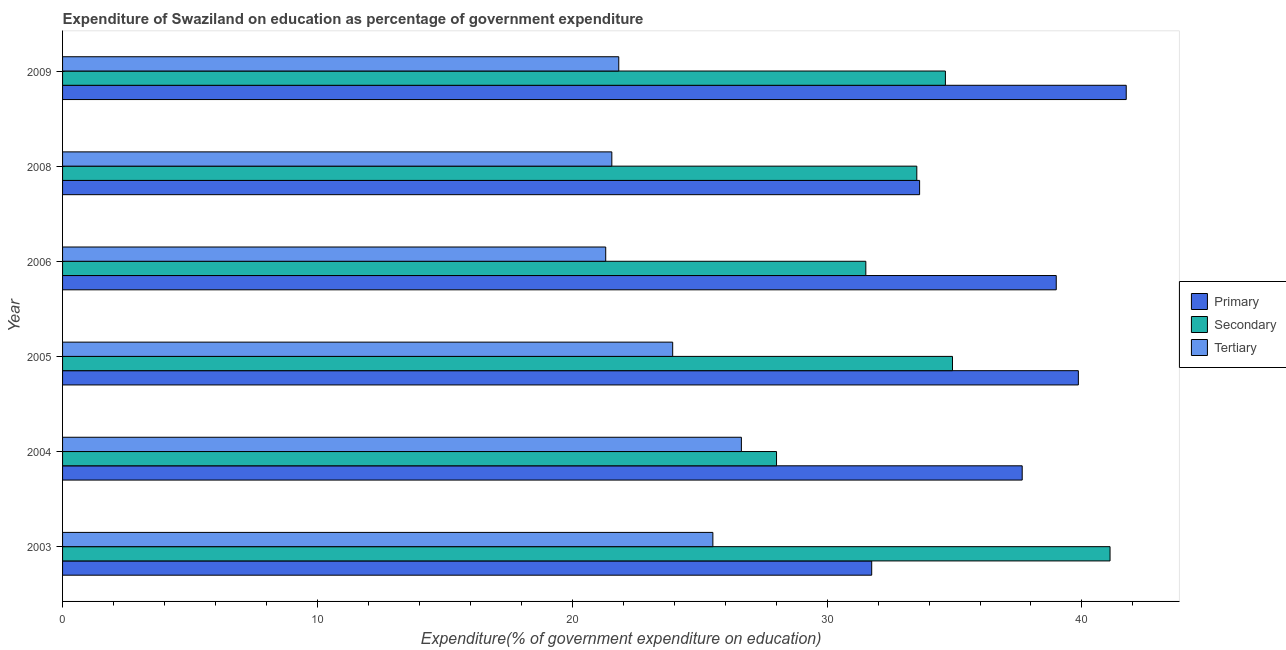Are the number of bars on each tick of the Y-axis equal?
Make the answer very short. Yes. What is the label of the 6th group of bars from the top?
Ensure brevity in your answer.  2003. What is the expenditure on secondary education in 2003?
Provide a succinct answer. 41.1. Across all years, what is the maximum expenditure on secondary education?
Offer a terse response. 41.1. Across all years, what is the minimum expenditure on primary education?
Offer a very short reply. 31.75. In which year was the expenditure on primary education maximum?
Offer a terse response. 2009. In which year was the expenditure on secondary education minimum?
Ensure brevity in your answer.  2004. What is the total expenditure on tertiary education in the graph?
Your answer should be very brief. 140.79. What is the difference between the expenditure on secondary education in 2004 and that in 2009?
Provide a short and direct response. -6.63. What is the difference between the expenditure on tertiary education in 2004 and the expenditure on primary education in 2005?
Give a very brief answer. -13.22. What is the average expenditure on tertiary education per year?
Ensure brevity in your answer.  23.46. In the year 2004, what is the difference between the expenditure on primary education and expenditure on tertiary education?
Offer a very short reply. 11.02. In how many years, is the expenditure on tertiary education greater than 10 %?
Your answer should be compact. 6. What is the ratio of the expenditure on secondary education in 2003 to that in 2005?
Your response must be concise. 1.18. What is the difference between the highest and the second highest expenditure on tertiary education?
Your answer should be compact. 1.12. What is the difference between the highest and the lowest expenditure on secondary education?
Provide a succinct answer. 13.09. In how many years, is the expenditure on primary education greater than the average expenditure on primary education taken over all years?
Make the answer very short. 4. Is the sum of the expenditure on primary education in 2003 and 2004 greater than the maximum expenditure on tertiary education across all years?
Your answer should be very brief. Yes. What does the 1st bar from the top in 2004 represents?
Offer a very short reply. Tertiary. What does the 2nd bar from the bottom in 2003 represents?
Make the answer very short. Secondary. Is it the case that in every year, the sum of the expenditure on primary education and expenditure on secondary education is greater than the expenditure on tertiary education?
Give a very brief answer. Yes. How many bars are there?
Your response must be concise. 18. How many years are there in the graph?
Offer a terse response. 6. What is the difference between two consecutive major ticks on the X-axis?
Provide a short and direct response. 10. Does the graph contain any zero values?
Make the answer very short. No. How many legend labels are there?
Offer a very short reply. 3. What is the title of the graph?
Offer a terse response. Expenditure of Swaziland on education as percentage of government expenditure. Does "Self-employed" appear as one of the legend labels in the graph?
Keep it short and to the point. No. What is the label or title of the X-axis?
Your answer should be compact. Expenditure(% of government expenditure on education). What is the label or title of the Y-axis?
Give a very brief answer. Year. What is the Expenditure(% of government expenditure on education) in Primary in 2003?
Your response must be concise. 31.75. What is the Expenditure(% of government expenditure on education) in Secondary in 2003?
Your answer should be compact. 41.1. What is the Expenditure(% of government expenditure on education) of Tertiary in 2003?
Your answer should be very brief. 25.52. What is the Expenditure(% of government expenditure on education) of Primary in 2004?
Provide a short and direct response. 37.66. What is the Expenditure(% of government expenditure on education) in Secondary in 2004?
Make the answer very short. 28.02. What is the Expenditure(% of government expenditure on education) in Tertiary in 2004?
Provide a short and direct response. 26.64. What is the Expenditure(% of government expenditure on education) of Primary in 2005?
Make the answer very short. 39.86. What is the Expenditure(% of government expenditure on education) of Secondary in 2005?
Ensure brevity in your answer.  34.92. What is the Expenditure(% of government expenditure on education) in Tertiary in 2005?
Give a very brief answer. 23.94. What is the Expenditure(% of government expenditure on education) of Primary in 2006?
Ensure brevity in your answer.  38.99. What is the Expenditure(% of government expenditure on education) of Secondary in 2006?
Ensure brevity in your answer.  31.52. What is the Expenditure(% of government expenditure on education) in Tertiary in 2006?
Your answer should be very brief. 21.31. What is the Expenditure(% of government expenditure on education) of Primary in 2008?
Your answer should be compact. 33.63. What is the Expenditure(% of government expenditure on education) in Secondary in 2008?
Your answer should be very brief. 33.52. What is the Expenditure(% of government expenditure on education) of Tertiary in 2008?
Your answer should be very brief. 21.55. What is the Expenditure(% of government expenditure on education) in Primary in 2009?
Offer a terse response. 41.74. What is the Expenditure(% of government expenditure on education) in Secondary in 2009?
Offer a terse response. 34.64. What is the Expenditure(% of government expenditure on education) in Tertiary in 2009?
Offer a terse response. 21.82. Across all years, what is the maximum Expenditure(% of government expenditure on education) of Primary?
Offer a terse response. 41.74. Across all years, what is the maximum Expenditure(% of government expenditure on education) in Secondary?
Make the answer very short. 41.1. Across all years, what is the maximum Expenditure(% of government expenditure on education) of Tertiary?
Ensure brevity in your answer.  26.64. Across all years, what is the minimum Expenditure(% of government expenditure on education) of Primary?
Give a very brief answer. 31.75. Across all years, what is the minimum Expenditure(% of government expenditure on education) of Secondary?
Offer a very short reply. 28.02. Across all years, what is the minimum Expenditure(% of government expenditure on education) of Tertiary?
Keep it short and to the point. 21.31. What is the total Expenditure(% of government expenditure on education) in Primary in the graph?
Keep it short and to the point. 223.62. What is the total Expenditure(% of government expenditure on education) in Secondary in the graph?
Provide a short and direct response. 203.72. What is the total Expenditure(% of government expenditure on education) of Tertiary in the graph?
Provide a short and direct response. 140.79. What is the difference between the Expenditure(% of government expenditure on education) of Primary in 2003 and that in 2004?
Your response must be concise. -5.91. What is the difference between the Expenditure(% of government expenditure on education) in Secondary in 2003 and that in 2004?
Keep it short and to the point. 13.09. What is the difference between the Expenditure(% of government expenditure on education) in Tertiary in 2003 and that in 2004?
Keep it short and to the point. -1.12. What is the difference between the Expenditure(% of government expenditure on education) in Primary in 2003 and that in 2005?
Your answer should be compact. -8.11. What is the difference between the Expenditure(% of government expenditure on education) in Secondary in 2003 and that in 2005?
Offer a terse response. 6.18. What is the difference between the Expenditure(% of government expenditure on education) of Tertiary in 2003 and that in 2005?
Ensure brevity in your answer.  1.58. What is the difference between the Expenditure(% of government expenditure on education) of Primary in 2003 and that in 2006?
Your response must be concise. -7.24. What is the difference between the Expenditure(% of government expenditure on education) of Secondary in 2003 and that in 2006?
Provide a short and direct response. 9.58. What is the difference between the Expenditure(% of government expenditure on education) in Tertiary in 2003 and that in 2006?
Offer a very short reply. 4.21. What is the difference between the Expenditure(% of government expenditure on education) of Primary in 2003 and that in 2008?
Your answer should be very brief. -1.88. What is the difference between the Expenditure(% of government expenditure on education) of Secondary in 2003 and that in 2008?
Make the answer very short. 7.58. What is the difference between the Expenditure(% of government expenditure on education) in Tertiary in 2003 and that in 2008?
Give a very brief answer. 3.97. What is the difference between the Expenditure(% of government expenditure on education) in Primary in 2003 and that in 2009?
Provide a succinct answer. -9.99. What is the difference between the Expenditure(% of government expenditure on education) in Secondary in 2003 and that in 2009?
Provide a short and direct response. 6.46. What is the difference between the Expenditure(% of government expenditure on education) in Tertiary in 2003 and that in 2009?
Offer a very short reply. 3.69. What is the difference between the Expenditure(% of government expenditure on education) of Primary in 2004 and that in 2005?
Make the answer very short. -2.2. What is the difference between the Expenditure(% of government expenditure on education) in Secondary in 2004 and that in 2005?
Ensure brevity in your answer.  -6.9. What is the difference between the Expenditure(% of government expenditure on education) of Tertiary in 2004 and that in 2005?
Offer a terse response. 2.7. What is the difference between the Expenditure(% of government expenditure on education) of Primary in 2004 and that in 2006?
Offer a very short reply. -1.34. What is the difference between the Expenditure(% of government expenditure on education) of Secondary in 2004 and that in 2006?
Keep it short and to the point. -3.5. What is the difference between the Expenditure(% of government expenditure on education) of Tertiary in 2004 and that in 2006?
Provide a succinct answer. 5.32. What is the difference between the Expenditure(% of government expenditure on education) of Primary in 2004 and that in 2008?
Your answer should be compact. 4.03. What is the difference between the Expenditure(% of government expenditure on education) of Secondary in 2004 and that in 2008?
Provide a short and direct response. -5.5. What is the difference between the Expenditure(% of government expenditure on education) in Tertiary in 2004 and that in 2008?
Your answer should be compact. 5.08. What is the difference between the Expenditure(% of government expenditure on education) in Primary in 2004 and that in 2009?
Your answer should be very brief. -4.08. What is the difference between the Expenditure(% of government expenditure on education) in Secondary in 2004 and that in 2009?
Make the answer very short. -6.63. What is the difference between the Expenditure(% of government expenditure on education) in Tertiary in 2004 and that in 2009?
Provide a short and direct response. 4.81. What is the difference between the Expenditure(% of government expenditure on education) of Primary in 2005 and that in 2006?
Ensure brevity in your answer.  0.87. What is the difference between the Expenditure(% of government expenditure on education) of Secondary in 2005 and that in 2006?
Keep it short and to the point. 3.4. What is the difference between the Expenditure(% of government expenditure on education) in Tertiary in 2005 and that in 2006?
Your response must be concise. 2.63. What is the difference between the Expenditure(% of government expenditure on education) in Primary in 2005 and that in 2008?
Ensure brevity in your answer.  6.23. What is the difference between the Expenditure(% of government expenditure on education) in Secondary in 2005 and that in 2008?
Your answer should be very brief. 1.4. What is the difference between the Expenditure(% of government expenditure on education) in Tertiary in 2005 and that in 2008?
Make the answer very short. 2.39. What is the difference between the Expenditure(% of government expenditure on education) in Primary in 2005 and that in 2009?
Keep it short and to the point. -1.88. What is the difference between the Expenditure(% of government expenditure on education) in Secondary in 2005 and that in 2009?
Give a very brief answer. 0.28. What is the difference between the Expenditure(% of government expenditure on education) in Tertiary in 2005 and that in 2009?
Offer a very short reply. 2.12. What is the difference between the Expenditure(% of government expenditure on education) in Primary in 2006 and that in 2008?
Provide a short and direct response. 5.36. What is the difference between the Expenditure(% of government expenditure on education) in Secondary in 2006 and that in 2008?
Offer a very short reply. -2. What is the difference between the Expenditure(% of government expenditure on education) of Tertiary in 2006 and that in 2008?
Your answer should be compact. -0.24. What is the difference between the Expenditure(% of government expenditure on education) in Primary in 2006 and that in 2009?
Offer a very short reply. -2.75. What is the difference between the Expenditure(% of government expenditure on education) of Secondary in 2006 and that in 2009?
Make the answer very short. -3.12. What is the difference between the Expenditure(% of government expenditure on education) in Tertiary in 2006 and that in 2009?
Provide a short and direct response. -0.51. What is the difference between the Expenditure(% of government expenditure on education) of Primary in 2008 and that in 2009?
Offer a very short reply. -8.11. What is the difference between the Expenditure(% of government expenditure on education) in Secondary in 2008 and that in 2009?
Your answer should be compact. -1.12. What is the difference between the Expenditure(% of government expenditure on education) in Tertiary in 2008 and that in 2009?
Offer a terse response. -0.27. What is the difference between the Expenditure(% of government expenditure on education) in Primary in 2003 and the Expenditure(% of government expenditure on education) in Secondary in 2004?
Give a very brief answer. 3.73. What is the difference between the Expenditure(% of government expenditure on education) of Primary in 2003 and the Expenditure(% of government expenditure on education) of Tertiary in 2004?
Your answer should be compact. 5.11. What is the difference between the Expenditure(% of government expenditure on education) of Secondary in 2003 and the Expenditure(% of government expenditure on education) of Tertiary in 2004?
Your response must be concise. 14.47. What is the difference between the Expenditure(% of government expenditure on education) of Primary in 2003 and the Expenditure(% of government expenditure on education) of Secondary in 2005?
Your response must be concise. -3.17. What is the difference between the Expenditure(% of government expenditure on education) of Primary in 2003 and the Expenditure(% of government expenditure on education) of Tertiary in 2005?
Keep it short and to the point. 7.81. What is the difference between the Expenditure(% of government expenditure on education) in Secondary in 2003 and the Expenditure(% of government expenditure on education) in Tertiary in 2005?
Offer a terse response. 17.16. What is the difference between the Expenditure(% of government expenditure on education) of Primary in 2003 and the Expenditure(% of government expenditure on education) of Secondary in 2006?
Make the answer very short. 0.23. What is the difference between the Expenditure(% of government expenditure on education) of Primary in 2003 and the Expenditure(% of government expenditure on education) of Tertiary in 2006?
Provide a short and direct response. 10.44. What is the difference between the Expenditure(% of government expenditure on education) of Secondary in 2003 and the Expenditure(% of government expenditure on education) of Tertiary in 2006?
Give a very brief answer. 19.79. What is the difference between the Expenditure(% of government expenditure on education) in Primary in 2003 and the Expenditure(% of government expenditure on education) in Secondary in 2008?
Keep it short and to the point. -1.77. What is the difference between the Expenditure(% of government expenditure on education) of Primary in 2003 and the Expenditure(% of government expenditure on education) of Tertiary in 2008?
Keep it short and to the point. 10.2. What is the difference between the Expenditure(% of government expenditure on education) of Secondary in 2003 and the Expenditure(% of government expenditure on education) of Tertiary in 2008?
Ensure brevity in your answer.  19.55. What is the difference between the Expenditure(% of government expenditure on education) of Primary in 2003 and the Expenditure(% of government expenditure on education) of Secondary in 2009?
Offer a terse response. -2.89. What is the difference between the Expenditure(% of government expenditure on education) of Primary in 2003 and the Expenditure(% of government expenditure on education) of Tertiary in 2009?
Make the answer very short. 9.92. What is the difference between the Expenditure(% of government expenditure on education) in Secondary in 2003 and the Expenditure(% of government expenditure on education) in Tertiary in 2009?
Give a very brief answer. 19.28. What is the difference between the Expenditure(% of government expenditure on education) in Primary in 2004 and the Expenditure(% of government expenditure on education) in Secondary in 2005?
Offer a terse response. 2.74. What is the difference between the Expenditure(% of government expenditure on education) of Primary in 2004 and the Expenditure(% of government expenditure on education) of Tertiary in 2005?
Offer a very short reply. 13.71. What is the difference between the Expenditure(% of government expenditure on education) of Secondary in 2004 and the Expenditure(% of government expenditure on education) of Tertiary in 2005?
Offer a terse response. 4.08. What is the difference between the Expenditure(% of government expenditure on education) of Primary in 2004 and the Expenditure(% of government expenditure on education) of Secondary in 2006?
Give a very brief answer. 6.14. What is the difference between the Expenditure(% of government expenditure on education) in Primary in 2004 and the Expenditure(% of government expenditure on education) in Tertiary in 2006?
Ensure brevity in your answer.  16.34. What is the difference between the Expenditure(% of government expenditure on education) in Secondary in 2004 and the Expenditure(% of government expenditure on education) in Tertiary in 2006?
Keep it short and to the point. 6.7. What is the difference between the Expenditure(% of government expenditure on education) in Primary in 2004 and the Expenditure(% of government expenditure on education) in Secondary in 2008?
Give a very brief answer. 4.14. What is the difference between the Expenditure(% of government expenditure on education) in Primary in 2004 and the Expenditure(% of government expenditure on education) in Tertiary in 2008?
Provide a short and direct response. 16.1. What is the difference between the Expenditure(% of government expenditure on education) of Secondary in 2004 and the Expenditure(% of government expenditure on education) of Tertiary in 2008?
Offer a very short reply. 6.46. What is the difference between the Expenditure(% of government expenditure on education) in Primary in 2004 and the Expenditure(% of government expenditure on education) in Secondary in 2009?
Your response must be concise. 3.01. What is the difference between the Expenditure(% of government expenditure on education) in Primary in 2004 and the Expenditure(% of government expenditure on education) in Tertiary in 2009?
Provide a succinct answer. 15.83. What is the difference between the Expenditure(% of government expenditure on education) of Secondary in 2004 and the Expenditure(% of government expenditure on education) of Tertiary in 2009?
Offer a terse response. 6.19. What is the difference between the Expenditure(% of government expenditure on education) of Primary in 2005 and the Expenditure(% of government expenditure on education) of Secondary in 2006?
Your response must be concise. 8.34. What is the difference between the Expenditure(% of government expenditure on education) of Primary in 2005 and the Expenditure(% of government expenditure on education) of Tertiary in 2006?
Offer a very short reply. 18.55. What is the difference between the Expenditure(% of government expenditure on education) in Secondary in 2005 and the Expenditure(% of government expenditure on education) in Tertiary in 2006?
Your answer should be very brief. 13.61. What is the difference between the Expenditure(% of government expenditure on education) in Primary in 2005 and the Expenditure(% of government expenditure on education) in Secondary in 2008?
Your response must be concise. 6.34. What is the difference between the Expenditure(% of government expenditure on education) of Primary in 2005 and the Expenditure(% of government expenditure on education) of Tertiary in 2008?
Your response must be concise. 18.31. What is the difference between the Expenditure(% of government expenditure on education) in Secondary in 2005 and the Expenditure(% of government expenditure on education) in Tertiary in 2008?
Ensure brevity in your answer.  13.37. What is the difference between the Expenditure(% of government expenditure on education) in Primary in 2005 and the Expenditure(% of government expenditure on education) in Secondary in 2009?
Your answer should be very brief. 5.22. What is the difference between the Expenditure(% of government expenditure on education) of Primary in 2005 and the Expenditure(% of government expenditure on education) of Tertiary in 2009?
Provide a succinct answer. 18.03. What is the difference between the Expenditure(% of government expenditure on education) of Secondary in 2005 and the Expenditure(% of government expenditure on education) of Tertiary in 2009?
Your answer should be compact. 13.09. What is the difference between the Expenditure(% of government expenditure on education) of Primary in 2006 and the Expenditure(% of government expenditure on education) of Secondary in 2008?
Your response must be concise. 5.47. What is the difference between the Expenditure(% of government expenditure on education) of Primary in 2006 and the Expenditure(% of government expenditure on education) of Tertiary in 2008?
Give a very brief answer. 17.44. What is the difference between the Expenditure(% of government expenditure on education) in Secondary in 2006 and the Expenditure(% of government expenditure on education) in Tertiary in 2008?
Your response must be concise. 9.97. What is the difference between the Expenditure(% of government expenditure on education) in Primary in 2006 and the Expenditure(% of government expenditure on education) in Secondary in 2009?
Provide a succinct answer. 4.35. What is the difference between the Expenditure(% of government expenditure on education) of Primary in 2006 and the Expenditure(% of government expenditure on education) of Tertiary in 2009?
Your answer should be compact. 17.17. What is the difference between the Expenditure(% of government expenditure on education) in Secondary in 2006 and the Expenditure(% of government expenditure on education) in Tertiary in 2009?
Make the answer very short. 9.69. What is the difference between the Expenditure(% of government expenditure on education) in Primary in 2008 and the Expenditure(% of government expenditure on education) in Secondary in 2009?
Your answer should be very brief. -1.01. What is the difference between the Expenditure(% of government expenditure on education) of Primary in 2008 and the Expenditure(% of government expenditure on education) of Tertiary in 2009?
Give a very brief answer. 11.8. What is the difference between the Expenditure(% of government expenditure on education) of Secondary in 2008 and the Expenditure(% of government expenditure on education) of Tertiary in 2009?
Make the answer very short. 11.7. What is the average Expenditure(% of government expenditure on education) of Primary per year?
Provide a short and direct response. 37.27. What is the average Expenditure(% of government expenditure on education) of Secondary per year?
Offer a very short reply. 33.95. What is the average Expenditure(% of government expenditure on education) of Tertiary per year?
Provide a short and direct response. 23.46. In the year 2003, what is the difference between the Expenditure(% of government expenditure on education) in Primary and Expenditure(% of government expenditure on education) in Secondary?
Offer a terse response. -9.35. In the year 2003, what is the difference between the Expenditure(% of government expenditure on education) in Primary and Expenditure(% of government expenditure on education) in Tertiary?
Ensure brevity in your answer.  6.23. In the year 2003, what is the difference between the Expenditure(% of government expenditure on education) of Secondary and Expenditure(% of government expenditure on education) of Tertiary?
Give a very brief answer. 15.58. In the year 2004, what is the difference between the Expenditure(% of government expenditure on education) of Primary and Expenditure(% of government expenditure on education) of Secondary?
Make the answer very short. 9.64. In the year 2004, what is the difference between the Expenditure(% of government expenditure on education) in Primary and Expenditure(% of government expenditure on education) in Tertiary?
Keep it short and to the point. 11.02. In the year 2004, what is the difference between the Expenditure(% of government expenditure on education) in Secondary and Expenditure(% of government expenditure on education) in Tertiary?
Give a very brief answer. 1.38. In the year 2005, what is the difference between the Expenditure(% of government expenditure on education) of Primary and Expenditure(% of government expenditure on education) of Secondary?
Ensure brevity in your answer.  4.94. In the year 2005, what is the difference between the Expenditure(% of government expenditure on education) in Primary and Expenditure(% of government expenditure on education) in Tertiary?
Make the answer very short. 15.92. In the year 2005, what is the difference between the Expenditure(% of government expenditure on education) of Secondary and Expenditure(% of government expenditure on education) of Tertiary?
Make the answer very short. 10.98. In the year 2006, what is the difference between the Expenditure(% of government expenditure on education) in Primary and Expenditure(% of government expenditure on education) in Secondary?
Provide a succinct answer. 7.47. In the year 2006, what is the difference between the Expenditure(% of government expenditure on education) of Primary and Expenditure(% of government expenditure on education) of Tertiary?
Offer a terse response. 17.68. In the year 2006, what is the difference between the Expenditure(% of government expenditure on education) in Secondary and Expenditure(% of government expenditure on education) in Tertiary?
Keep it short and to the point. 10.21. In the year 2008, what is the difference between the Expenditure(% of government expenditure on education) of Primary and Expenditure(% of government expenditure on education) of Secondary?
Your response must be concise. 0.11. In the year 2008, what is the difference between the Expenditure(% of government expenditure on education) of Primary and Expenditure(% of government expenditure on education) of Tertiary?
Provide a short and direct response. 12.08. In the year 2008, what is the difference between the Expenditure(% of government expenditure on education) of Secondary and Expenditure(% of government expenditure on education) of Tertiary?
Offer a terse response. 11.97. In the year 2009, what is the difference between the Expenditure(% of government expenditure on education) in Primary and Expenditure(% of government expenditure on education) in Secondary?
Ensure brevity in your answer.  7.1. In the year 2009, what is the difference between the Expenditure(% of government expenditure on education) of Primary and Expenditure(% of government expenditure on education) of Tertiary?
Offer a terse response. 19.91. In the year 2009, what is the difference between the Expenditure(% of government expenditure on education) in Secondary and Expenditure(% of government expenditure on education) in Tertiary?
Your answer should be compact. 12.82. What is the ratio of the Expenditure(% of government expenditure on education) in Primary in 2003 to that in 2004?
Keep it short and to the point. 0.84. What is the ratio of the Expenditure(% of government expenditure on education) in Secondary in 2003 to that in 2004?
Offer a terse response. 1.47. What is the ratio of the Expenditure(% of government expenditure on education) in Tertiary in 2003 to that in 2004?
Ensure brevity in your answer.  0.96. What is the ratio of the Expenditure(% of government expenditure on education) in Primary in 2003 to that in 2005?
Provide a succinct answer. 0.8. What is the ratio of the Expenditure(% of government expenditure on education) of Secondary in 2003 to that in 2005?
Offer a terse response. 1.18. What is the ratio of the Expenditure(% of government expenditure on education) in Tertiary in 2003 to that in 2005?
Offer a very short reply. 1.07. What is the ratio of the Expenditure(% of government expenditure on education) in Primary in 2003 to that in 2006?
Your response must be concise. 0.81. What is the ratio of the Expenditure(% of government expenditure on education) in Secondary in 2003 to that in 2006?
Your answer should be compact. 1.3. What is the ratio of the Expenditure(% of government expenditure on education) in Tertiary in 2003 to that in 2006?
Keep it short and to the point. 1.2. What is the ratio of the Expenditure(% of government expenditure on education) of Primary in 2003 to that in 2008?
Your response must be concise. 0.94. What is the ratio of the Expenditure(% of government expenditure on education) in Secondary in 2003 to that in 2008?
Offer a very short reply. 1.23. What is the ratio of the Expenditure(% of government expenditure on education) of Tertiary in 2003 to that in 2008?
Provide a short and direct response. 1.18. What is the ratio of the Expenditure(% of government expenditure on education) in Primary in 2003 to that in 2009?
Offer a terse response. 0.76. What is the ratio of the Expenditure(% of government expenditure on education) of Secondary in 2003 to that in 2009?
Your response must be concise. 1.19. What is the ratio of the Expenditure(% of government expenditure on education) of Tertiary in 2003 to that in 2009?
Offer a terse response. 1.17. What is the ratio of the Expenditure(% of government expenditure on education) of Primary in 2004 to that in 2005?
Keep it short and to the point. 0.94. What is the ratio of the Expenditure(% of government expenditure on education) in Secondary in 2004 to that in 2005?
Offer a very short reply. 0.8. What is the ratio of the Expenditure(% of government expenditure on education) in Tertiary in 2004 to that in 2005?
Your answer should be very brief. 1.11. What is the ratio of the Expenditure(% of government expenditure on education) of Primary in 2004 to that in 2006?
Provide a succinct answer. 0.97. What is the ratio of the Expenditure(% of government expenditure on education) in Secondary in 2004 to that in 2006?
Ensure brevity in your answer.  0.89. What is the ratio of the Expenditure(% of government expenditure on education) of Tertiary in 2004 to that in 2006?
Provide a succinct answer. 1.25. What is the ratio of the Expenditure(% of government expenditure on education) in Primary in 2004 to that in 2008?
Give a very brief answer. 1.12. What is the ratio of the Expenditure(% of government expenditure on education) of Secondary in 2004 to that in 2008?
Give a very brief answer. 0.84. What is the ratio of the Expenditure(% of government expenditure on education) of Tertiary in 2004 to that in 2008?
Your answer should be compact. 1.24. What is the ratio of the Expenditure(% of government expenditure on education) in Primary in 2004 to that in 2009?
Your answer should be very brief. 0.9. What is the ratio of the Expenditure(% of government expenditure on education) in Secondary in 2004 to that in 2009?
Provide a succinct answer. 0.81. What is the ratio of the Expenditure(% of government expenditure on education) in Tertiary in 2004 to that in 2009?
Offer a terse response. 1.22. What is the ratio of the Expenditure(% of government expenditure on education) of Primary in 2005 to that in 2006?
Your answer should be very brief. 1.02. What is the ratio of the Expenditure(% of government expenditure on education) of Secondary in 2005 to that in 2006?
Offer a terse response. 1.11. What is the ratio of the Expenditure(% of government expenditure on education) of Tertiary in 2005 to that in 2006?
Give a very brief answer. 1.12. What is the ratio of the Expenditure(% of government expenditure on education) in Primary in 2005 to that in 2008?
Ensure brevity in your answer.  1.19. What is the ratio of the Expenditure(% of government expenditure on education) in Secondary in 2005 to that in 2008?
Make the answer very short. 1.04. What is the ratio of the Expenditure(% of government expenditure on education) in Tertiary in 2005 to that in 2008?
Give a very brief answer. 1.11. What is the ratio of the Expenditure(% of government expenditure on education) of Primary in 2005 to that in 2009?
Your answer should be compact. 0.95. What is the ratio of the Expenditure(% of government expenditure on education) of Tertiary in 2005 to that in 2009?
Provide a short and direct response. 1.1. What is the ratio of the Expenditure(% of government expenditure on education) of Primary in 2006 to that in 2008?
Your answer should be compact. 1.16. What is the ratio of the Expenditure(% of government expenditure on education) in Secondary in 2006 to that in 2008?
Keep it short and to the point. 0.94. What is the ratio of the Expenditure(% of government expenditure on education) of Tertiary in 2006 to that in 2008?
Your answer should be very brief. 0.99. What is the ratio of the Expenditure(% of government expenditure on education) in Primary in 2006 to that in 2009?
Give a very brief answer. 0.93. What is the ratio of the Expenditure(% of government expenditure on education) in Secondary in 2006 to that in 2009?
Provide a short and direct response. 0.91. What is the ratio of the Expenditure(% of government expenditure on education) in Tertiary in 2006 to that in 2009?
Your answer should be compact. 0.98. What is the ratio of the Expenditure(% of government expenditure on education) in Primary in 2008 to that in 2009?
Your response must be concise. 0.81. What is the ratio of the Expenditure(% of government expenditure on education) of Secondary in 2008 to that in 2009?
Offer a very short reply. 0.97. What is the ratio of the Expenditure(% of government expenditure on education) in Tertiary in 2008 to that in 2009?
Offer a very short reply. 0.99. What is the difference between the highest and the second highest Expenditure(% of government expenditure on education) in Primary?
Offer a very short reply. 1.88. What is the difference between the highest and the second highest Expenditure(% of government expenditure on education) in Secondary?
Make the answer very short. 6.18. What is the difference between the highest and the second highest Expenditure(% of government expenditure on education) in Tertiary?
Provide a succinct answer. 1.12. What is the difference between the highest and the lowest Expenditure(% of government expenditure on education) of Primary?
Offer a very short reply. 9.99. What is the difference between the highest and the lowest Expenditure(% of government expenditure on education) of Secondary?
Make the answer very short. 13.09. What is the difference between the highest and the lowest Expenditure(% of government expenditure on education) in Tertiary?
Provide a short and direct response. 5.32. 